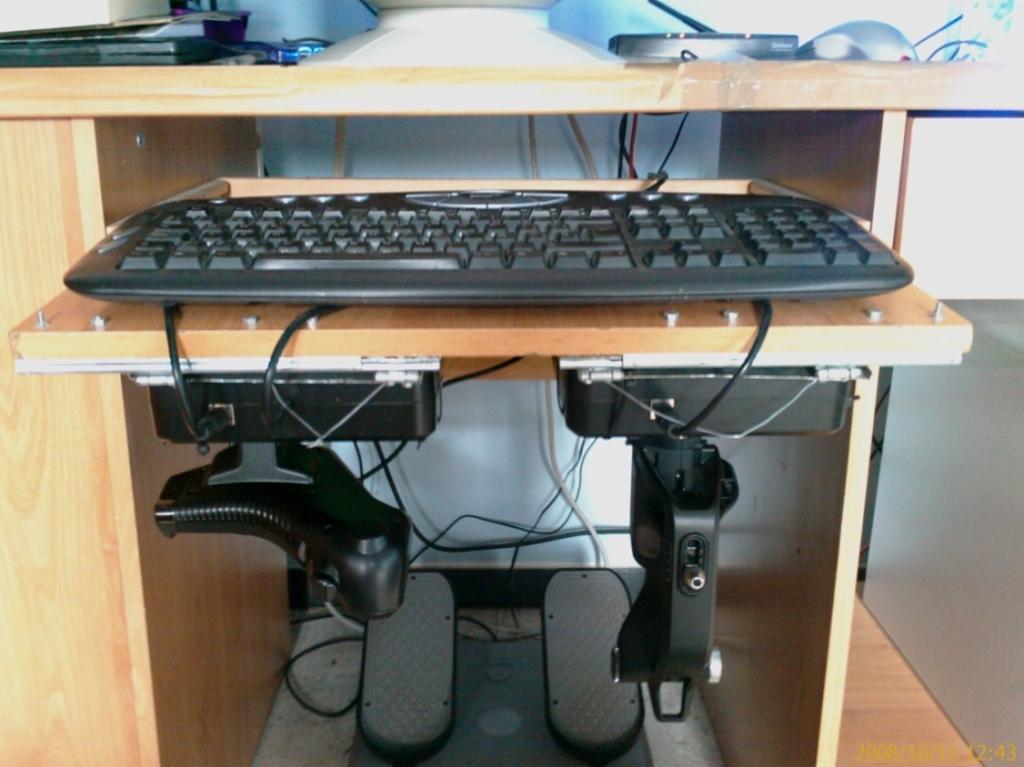Can you describe this image briefly? in this picture we can see a keyboard on the table ,and wires attached to it, and in front a wall ,and there are some other objects on the table. 